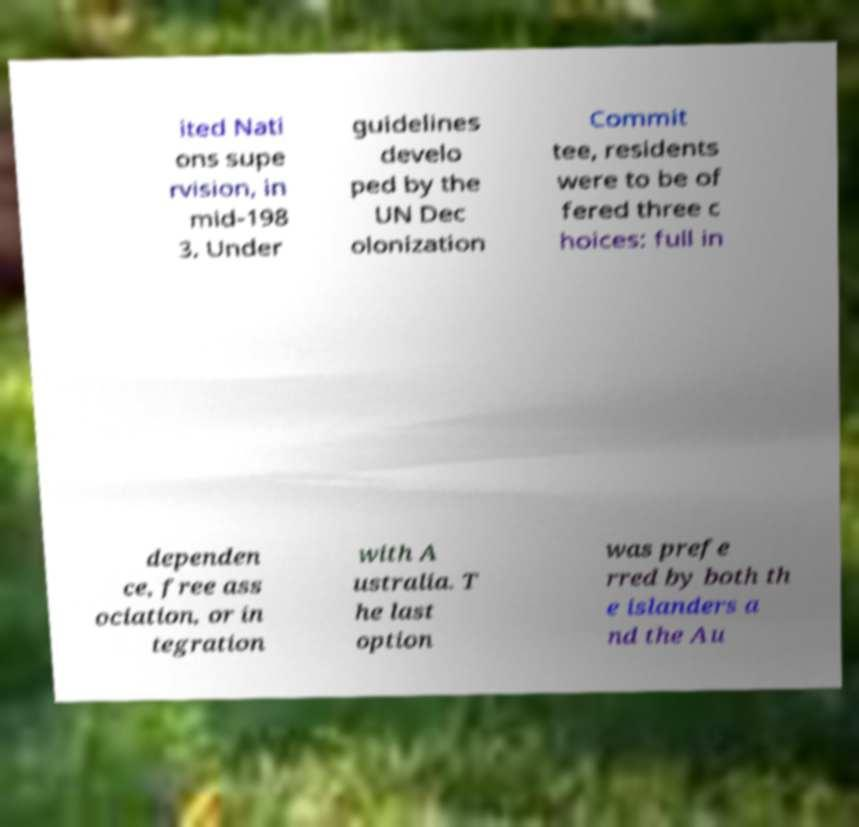Could you assist in decoding the text presented in this image and type it out clearly? ited Nati ons supe rvision, in mid-198 3. Under guidelines develo ped by the UN Dec olonization Commit tee, residents were to be of fered three c hoices: full in dependen ce, free ass ociation, or in tegration with A ustralia. T he last option was prefe rred by both th e islanders a nd the Au 